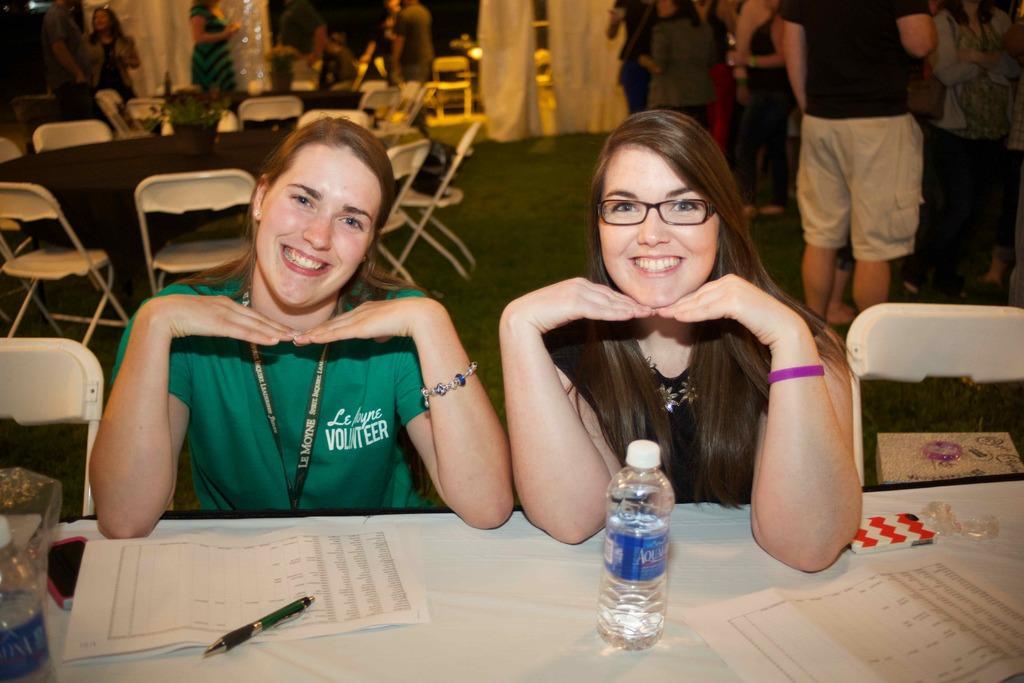How would you summarize this image in a sentence or two? These are two girls sitting on the chairs resting their hands on the table. This girl is smiling wearing ID card. This girl also smiling behind them there are chairs and tables the right side of an image there are few people standing and the left side of an image a woman is moving around. 